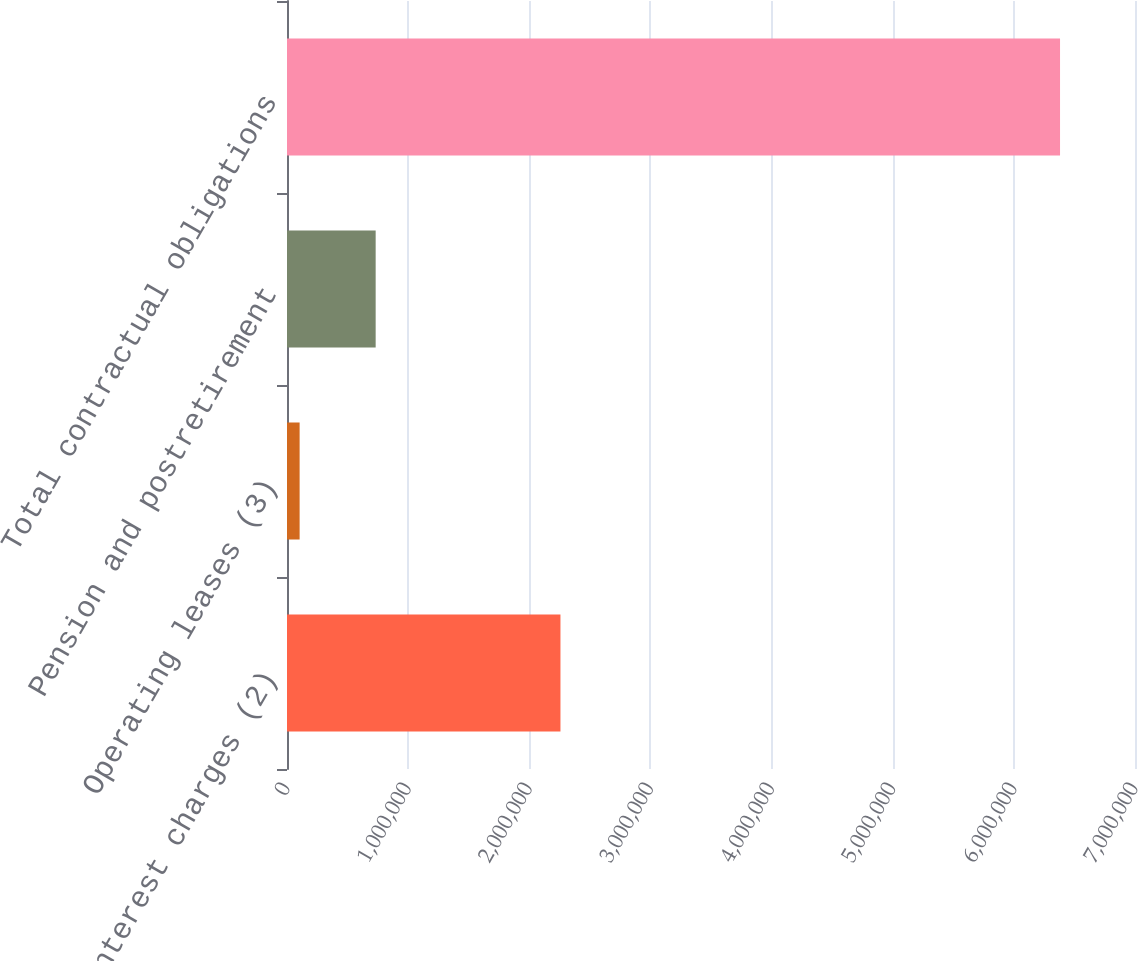<chart> <loc_0><loc_0><loc_500><loc_500><bar_chart><fcel>Interest charges (2)<fcel>Operating leases (3)<fcel>Pension and postretirement<fcel>Total contractual obligations<nl><fcel>2.25731e+06<fcel>104191<fcel>731894<fcel>6.38122e+06<nl></chart> 